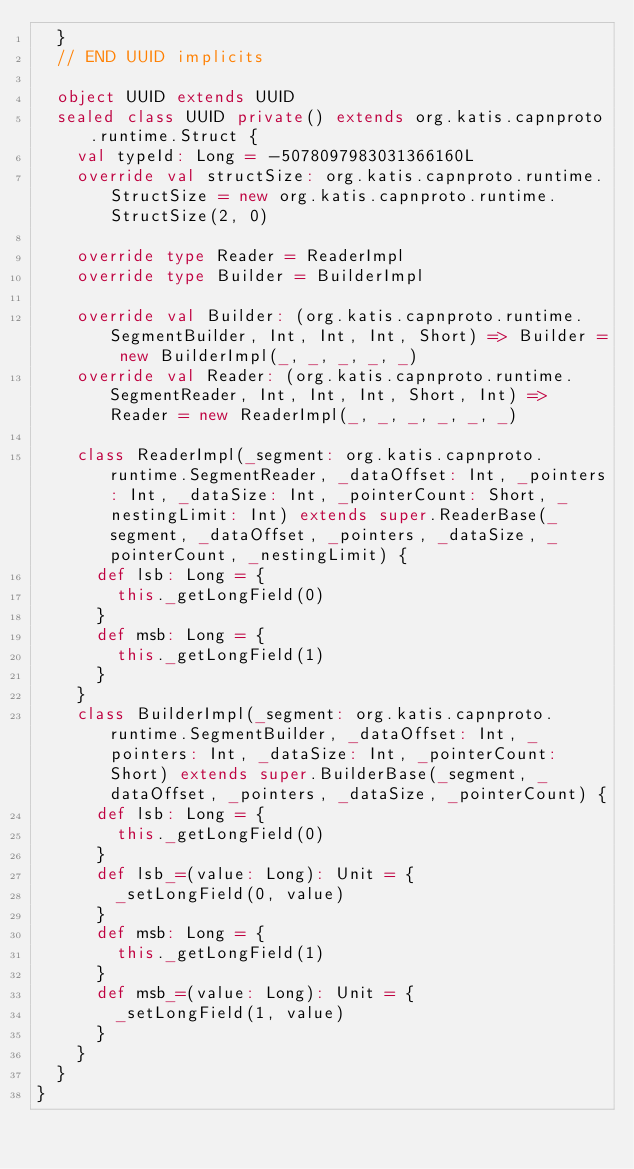Convert code to text. <code><loc_0><loc_0><loc_500><loc_500><_Scala_>  }
  // END UUID implicits

  object UUID extends UUID
  sealed class UUID private() extends org.katis.capnproto.runtime.Struct { 
    val typeId: Long = -5078097983031366160L
    override val structSize: org.katis.capnproto.runtime.StructSize = new org.katis.capnproto.runtime.StructSize(2, 0)

    override type Reader = ReaderImpl
    override type Builder = BuilderImpl

    override val Builder: (org.katis.capnproto.runtime.SegmentBuilder, Int, Int, Int, Short) => Builder = new BuilderImpl(_, _, _, _, _)
    override val Reader: (org.katis.capnproto.runtime.SegmentReader, Int, Int, Int, Short, Int) => Reader = new ReaderImpl(_, _, _, _, _, _)

    class ReaderImpl(_segment: org.katis.capnproto.runtime.SegmentReader, _dataOffset: Int, _pointers: Int, _dataSize: Int, _pointerCount: Short, _nestingLimit: Int) extends super.ReaderBase(_segment, _dataOffset, _pointers, _dataSize, _pointerCount, _nestingLimit) {
      def lsb: Long = {
        this._getLongField(0)
      }
      def msb: Long = {
        this._getLongField(1)
      }
    }
    class BuilderImpl(_segment: org.katis.capnproto.runtime.SegmentBuilder, _dataOffset: Int, _pointers: Int, _dataSize: Int, _pointerCount: Short) extends super.BuilderBase(_segment, _dataOffset, _pointers, _dataSize, _pointerCount) {
      def lsb: Long = {
        this._getLongField(0)
      }
      def lsb_=(value: Long): Unit = {
        _setLongField(0, value)
      }
      def msb: Long = {
        this._getLongField(1)
      }
      def msb_=(value: Long): Unit = {
        _setLongField(1, value)
      }
    }
  }
}
</code> 